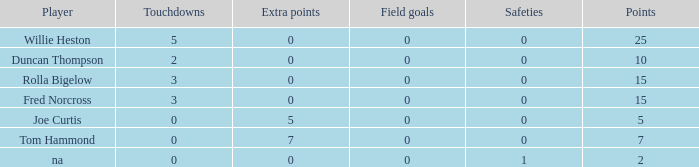Which Points is the lowest one that has Touchdowns smaller than 2, and an Extra points of 7, and a Field goals smaller than 0? None. 